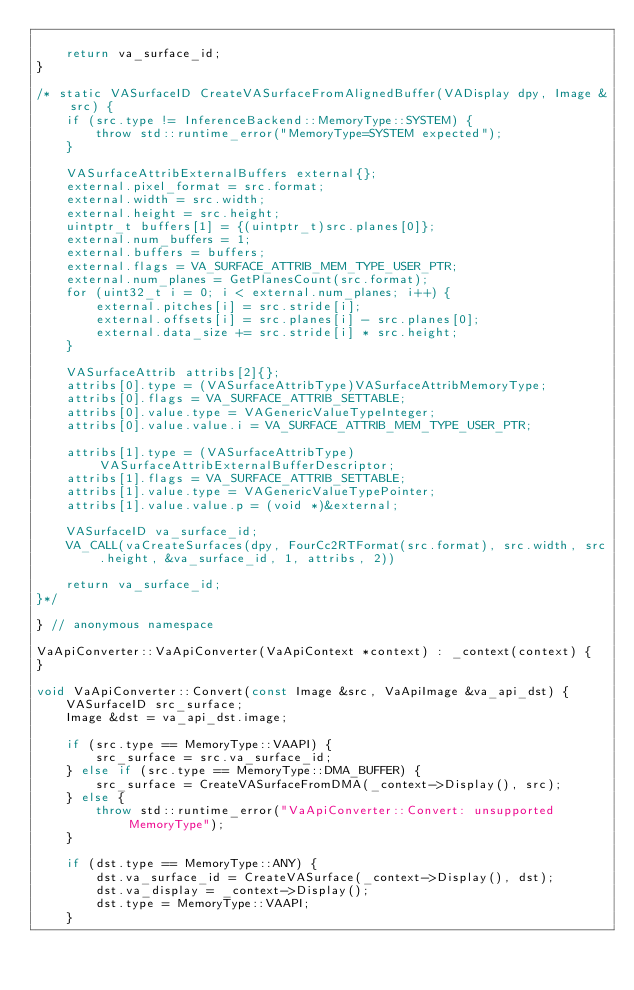<code> <loc_0><loc_0><loc_500><loc_500><_C++_>
    return va_surface_id;
}

/* static VASurfaceID CreateVASurfaceFromAlignedBuffer(VADisplay dpy, Image &src) {
    if (src.type != InferenceBackend::MemoryType::SYSTEM) {
        throw std::runtime_error("MemoryType=SYSTEM expected");
    }

    VASurfaceAttribExternalBuffers external{};
    external.pixel_format = src.format;
    external.width = src.width;
    external.height = src.height;
    uintptr_t buffers[1] = {(uintptr_t)src.planes[0]};
    external.num_buffers = 1;
    external.buffers = buffers;
    external.flags = VA_SURFACE_ATTRIB_MEM_TYPE_USER_PTR;
    external.num_planes = GetPlanesCount(src.format);
    for (uint32_t i = 0; i < external.num_planes; i++) {
        external.pitches[i] = src.stride[i];
        external.offsets[i] = src.planes[i] - src.planes[0];
        external.data_size += src.stride[i] * src.height;
    }

    VASurfaceAttrib attribs[2]{};
    attribs[0].type = (VASurfaceAttribType)VASurfaceAttribMemoryType;
    attribs[0].flags = VA_SURFACE_ATTRIB_SETTABLE;
    attribs[0].value.type = VAGenericValueTypeInteger;
    attribs[0].value.value.i = VA_SURFACE_ATTRIB_MEM_TYPE_USER_PTR;

    attribs[1].type = (VASurfaceAttribType)VASurfaceAttribExternalBufferDescriptor;
    attribs[1].flags = VA_SURFACE_ATTRIB_SETTABLE;
    attribs[1].value.type = VAGenericValueTypePointer;
    attribs[1].value.value.p = (void *)&external;

    VASurfaceID va_surface_id;
    VA_CALL(vaCreateSurfaces(dpy, FourCc2RTFormat(src.format), src.width, src.height, &va_surface_id, 1, attribs, 2))

    return va_surface_id;
}*/

} // anonymous namespace

VaApiConverter::VaApiConverter(VaApiContext *context) : _context(context) {
}

void VaApiConverter::Convert(const Image &src, VaApiImage &va_api_dst) {
    VASurfaceID src_surface;
    Image &dst = va_api_dst.image;

    if (src.type == MemoryType::VAAPI) {
        src_surface = src.va_surface_id;
    } else if (src.type == MemoryType::DMA_BUFFER) {
        src_surface = CreateVASurfaceFromDMA(_context->Display(), src);
    } else {
        throw std::runtime_error("VaApiConverter::Convert: unsupported MemoryType");
    }

    if (dst.type == MemoryType::ANY) {
        dst.va_surface_id = CreateVASurface(_context->Display(), dst);
        dst.va_display = _context->Display();
        dst.type = MemoryType::VAAPI;
    }</code> 